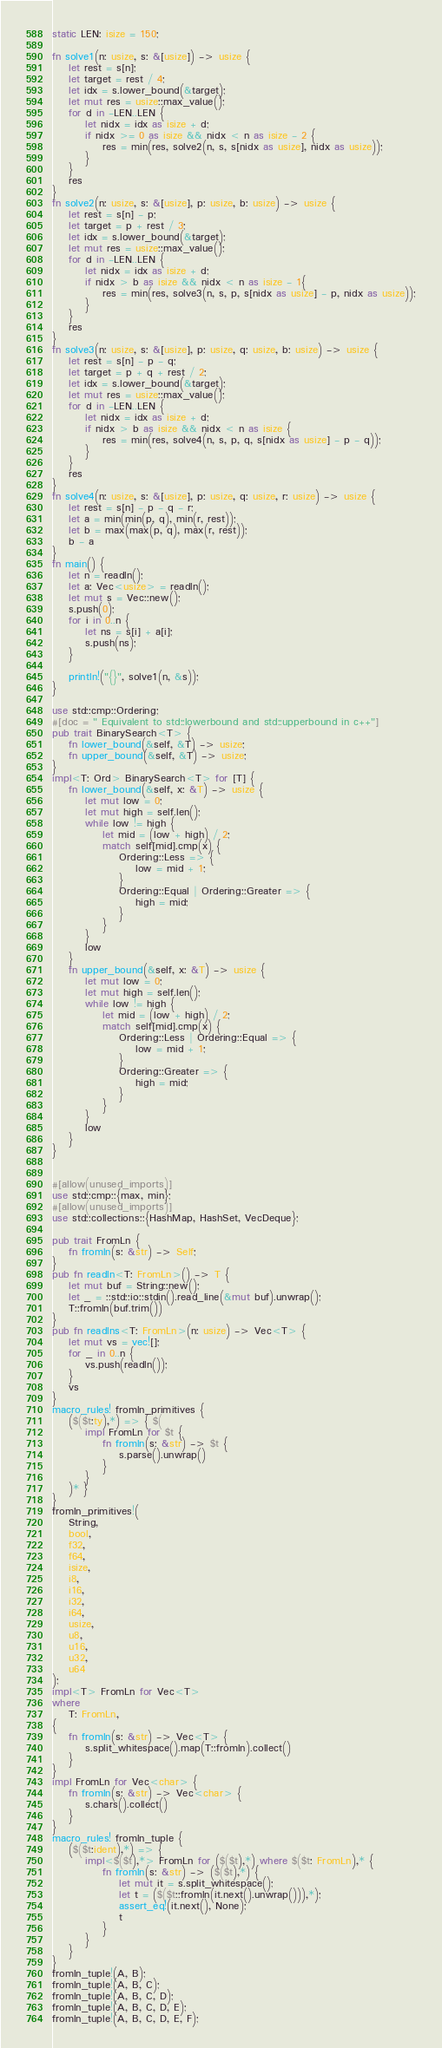<code> <loc_0><loc_0><loc_500><loc_500><_Rust_>static LEN: isize = 150;

fn solve1(n: usize, s: &[usize]) -> usize {
    let rest = s[n];
    let target = rest / 4;
    let idx = s.lower_bound(&target);
    let mut res = usize::max_value();
    for d in -LEN..LEN {
        let nidx = idx as isize + d;
        if nidx >= 0 as isize && nidx < n as isize - 2 {
            res = min(res, solve2(n, s, s[nidx as usize], nidx as usize));
        }
    }
    res
}
fn solve2(n: usize, s: &[usize], p: usize, b: usize) -> usize {
    let rest = s[n] - p;
    let target = p + rest / 3;
    let idx = s.lower_bound(&target);
    let mut res = usize::max_value();
    for d in -LEN..LEN {
        let nidx = idx as isize + d;
        if nidx > b as isize && nidx < n as isize - 1{
            res = min(res, solve3(n, s, p, s[nidx as usize] - p, nidx as usize));
        }
    }
    res
}
fn solve3(n: usize, s: &[usize], p: usize, q: usize, b: usize) -> usize {
    let rest = s[n] - p - q;
    let target = p + q + rest / 2;
    let idx = s.lower_bound(&target);
    let mut res = usize::max_value();
    for d in -LEN..LEN {
        let nidx = idx as isize + d;
        if nidx > b as isize && nidx < n as isize {
            res = min(res, solve4(n, s, p, q, s[nidx as usize] - p - q));
        }
    }
    res
}
fn solve4(n: usize, s: &[usize], p: usize, q: usize, r: usize) -> usize {
    let rest = s[n] - p - q - r;
    let a = min(min(p, q), min(r, rest));
    let b = max(max(p, q), max(r, rest));
    b - a
}
fn main() {
    let n = readln();
    let a: Vec<usize> = readln();
    let mut s = Vec::new();
    s.push(0);
    for i in 0..n {
        let ns = s[i] + a[i];
        s.push(ns);
    }

    println!("{}", solve1(n, &s));
}

use std::cmp::Ordering;
#[doc = " Equivalent to std::lowerbound and std::upperbound in c++"]
pub trait BinarySearch<T> {
    fn lower_bound(&self, &T) -> usize;
    fn upper_bound(&self, &T) -> usize;
}
impl<T: Ord> BinarySearch<T> for [T] {
    fn lower_bound(&self, x: &T) -> usize {
        let mut low = 0;
        let mut high = self.len();
        while low != high {
            let mid = (low + high) / 2;
            match self[mid].cmp(x) {
                Ordering::Less => {
                    low = mid + 1;
                }
                Ordering::Equal | Ordering::Greater => {
                    high = mid;
                }
            }
        }
        low
    }
    fn upper_bound(&self, x: &T) -> usize {
        let mut low = 0;
        let mut high = self.len();
        while low != high {
            let mid = (low + high) / 2;
            match self[mid].cmp(x) {
                Ordering::Less | Ordering::Equal => {
                    low = mid + 1;
                }
                Ordering::Greater => {
                    high = mid;
                }
            }
        }
        low
    }
}


#[allow(unused_imports)]
use std::cmp::{max, min};
#[allow(unused_imports)]
use std::collections::{HashMap, HashSet, VecDeque};

pub trait FromLn {
    fn fromln(s: &str) -> Self;
}
pub fn readln<T: FromLn>() -> T {
    let mut buf = String::new();
    let _ = ::std::io::stdin().read_line(&mut buf).unwrap();
    T::fromln(buf.trim())
}
pub fn readlns<T: FromLn>(n: usize) -> Vec<T> {
    let mut vs = vec![];
    for _ in 0..n {
        vs.push(readln());
    }
    vs
}
macro_rules! fromln_primitives {
    ($($t:ty),*) => { $(
        impl FromLn for $t {
            fn fromln(s: &str) -> $t {
                s.parse().unwrap()
            }
        }
    )* }
}
fromln_primitives!(
    String,
    bool,
    f32,
    f64,
    isize,
    i8,
    i16,
    i32,
    i64,
    usize,
    u8,
    u16,
    u32,
    u64
);
impl<T> FromLn for Vec<T>
where
    T: FromLn,
{
    fn fromln(s: &str) -> Vec<T> {
        s.split_whitespace().map(T::fromln).collect()
    }
}
impl FromLn for Vec<char> {
    fn fromln(s: &str) -> Vec<char> {
        s.chars().collect()
    }
}
macro_rules! fromln_tuple {
    ($($t:ident),*) => {
        impl<$($t),*> FromLn for ($($t),*) where $($t: FromLn),* {
            fn fromln(s: &str) -> ($($t),*) {
                let mut it = s.split_whitespace();
                let t = ($($t::fromln(it.next().unwrap())),*);
                assert_eq!(it.next(), None);
                t
            }
        }
    }
}
fromln_tuple!(A, B);
fromln_tuple!(A, B, C);
fromln_tuple!(A, B, C, D);
fromln_tuple!(A, B, C, D, E);
fromln_tuple!(A, B, C, D, E, F);
</code> 